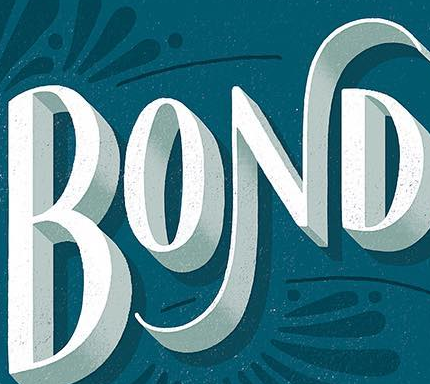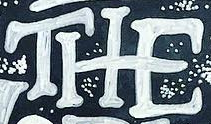What words can you see in these images in sequence, separated by a semicolon? BOND; THE 